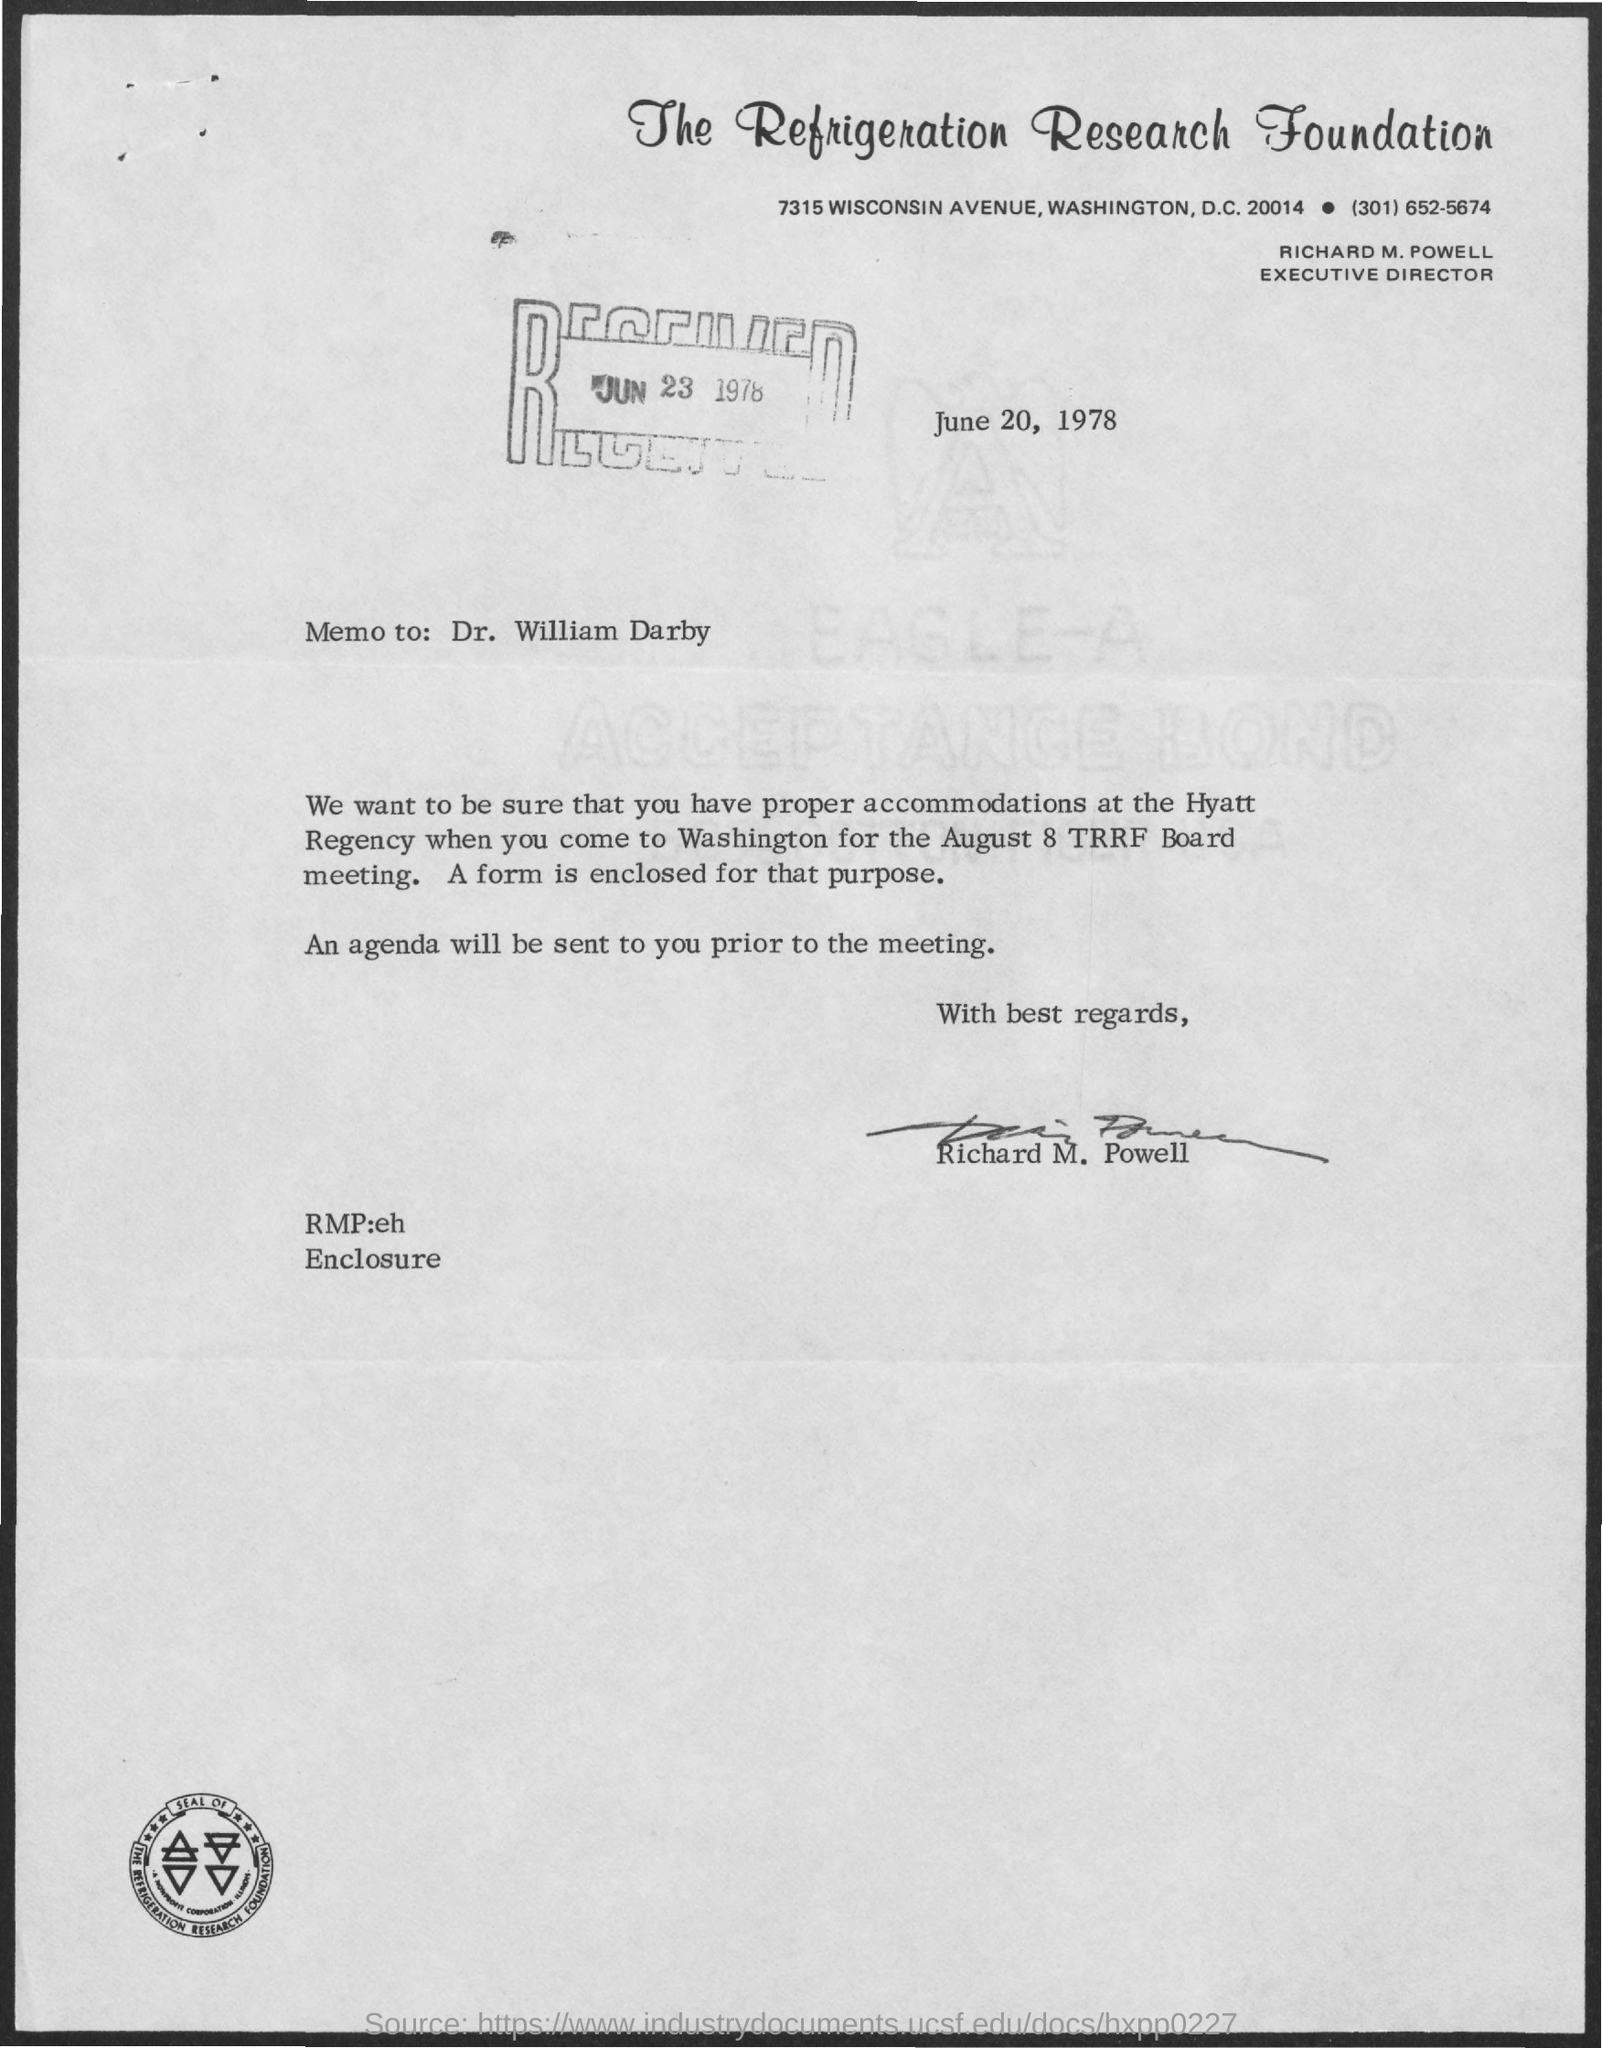Specify some key components in this picture. The letter was signed "Richard M. Powell. The Refrigeration Research Foundation is the name of the foundation mentioned. Richard M. Powell is the executive director. The received date mentioned is June 23, 1978. The date mentioned in the given page is June 20, 1978. 